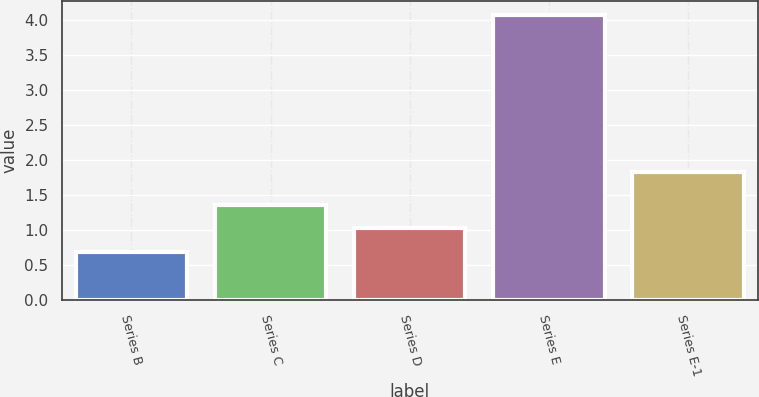Convert chart to OTSL. <chart><loc_0><loc_0><loc_500><loc_500><bar_chart><fcel>Series B<fcel>Series C<fcel>Series D<fcel>Series E<fcel>Series E-1<nl><fcel>0.68<fcel>1.36<fcel>1.02<fcel>4.07<fcel>1.82<nl></chart> 